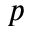<formula> <loc_0><loc_0><loc_500><loc_500>p</formula> 